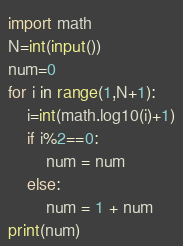Convert code to text. <code><loc_0><loc_0><loc_500><loc_500><_Python_>import math
N=int(input())
num=0
for i in range(1,N+1):
    i=int(math.log10(i)+1)
    if i%2==0:
        num = num
    else:
        num = 1 + num
print(num)</code> 